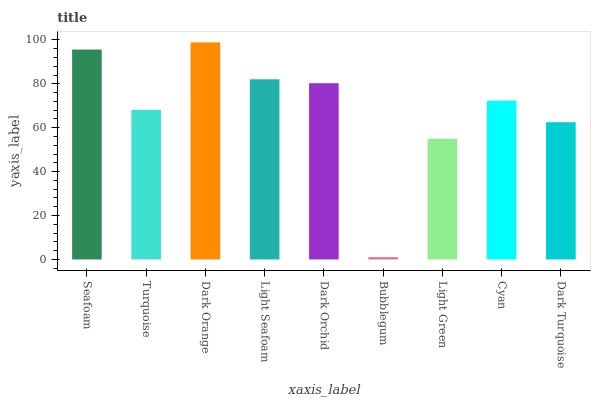Is Bubblegum the minimum?
Answer yes or no. Yes. Is Dark Orange the maximum?
Answer yes or no. Yes. Is Turquoise the minimum?
Answer yes or no. No. Is Turquoise the maximum?
Answer yes or no. No. Is Seafoam greater than Turquoise?
Answer yes or no. Yes. Is Turquoise less than Seafoam?
Answer yes or no. Yes. Is Turquoise greater than Seafoam?
Answer yes or no. No. Is Seafoam less than Turquoise?
Answer yes or no. No. Is Cyan the high median?
Answer yes or no. Yes. Is Cyan the low median?
Answer yes or no. Yes. Is Bubblegum the high median?
Answer yes or no. No. Is Dark Orchid the low median?
Answer yes or no. No. 